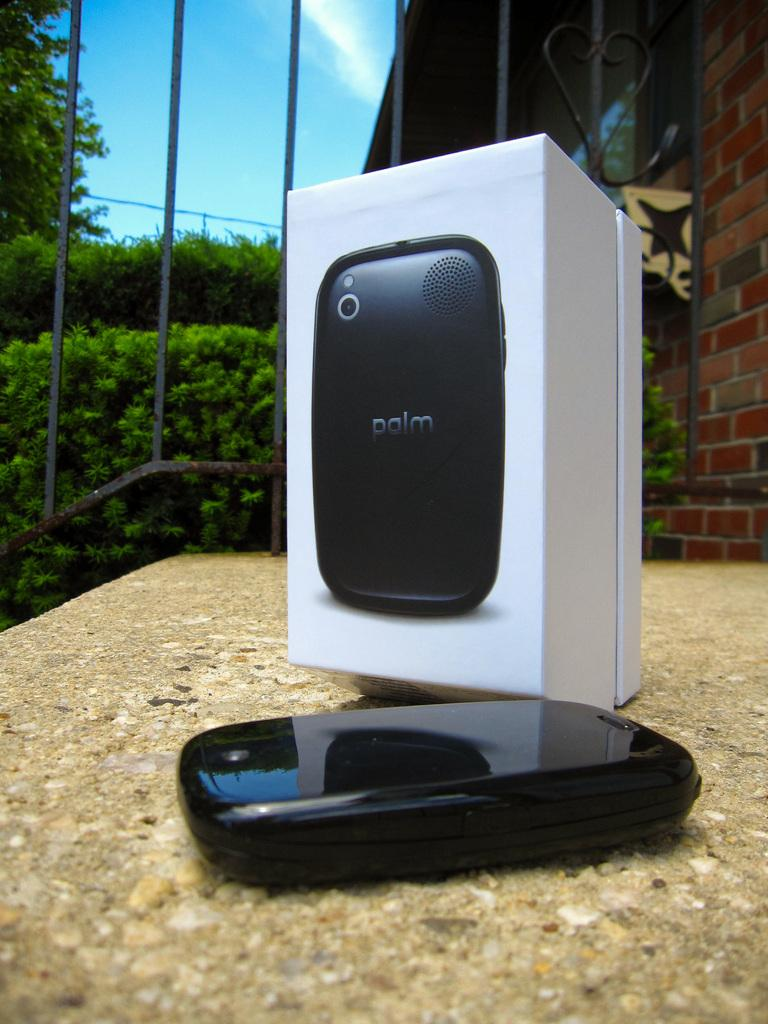<image>
Give a short and clear explanation of the subsequent image. Black electronic device made by Palm laying down. 